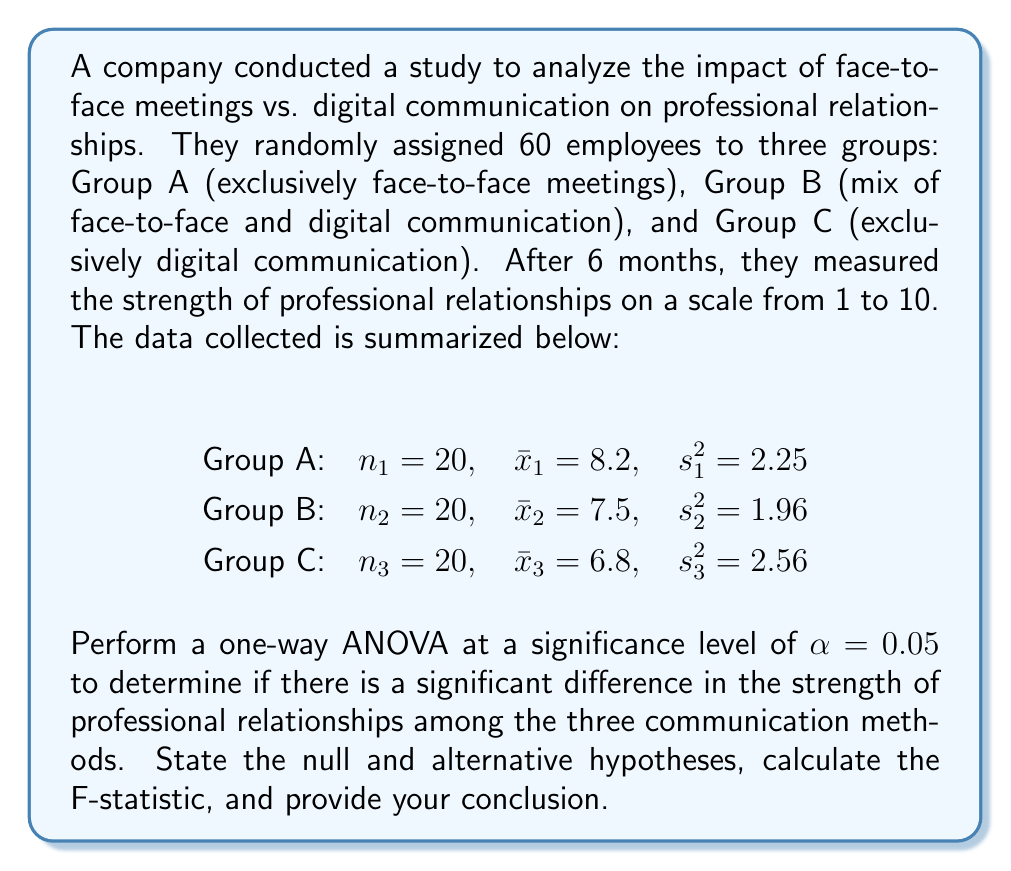Give your solution to this math problem. To perform a one-way ANOVA, we'll follow these steps:

1. State the null and alternative hypotheses:
   $H_0: \mu_1 = \mu_2 = \mu_3$ (There is no difference in mean relationship strength among the groups)
   $H_a:$ At least one mean is different

2. Calculate the sum of squares between groups (SSB):
   $$SSB = \sum_{i=1}^k n_i(\bar{x}_i - \bar{x})^2$$
   
   First, we need to calculate the grand mean:
   $$\bar{x} = \frac{20(8.2) + 20(7.5) + 20(6.8)}{60} = 7.5$$

   Now, we can calculate SSB:
   $$SSB = 20(8.2 - 7.5)^2 + 20(7.5 - 7.5)^2 + 20(6.8 - 7.5)^2 = 19.6$$

3. Calculate the sum of squares within groups (SSW):
   $$SSW = \sum_{i=1}^k (n_i - 1)s_i^2$$
   $$SSW = 19(2.25) + 19(1.96) + 19(2.56) = 128.63$$

4. Calculate the degrees of freedom:
   $df_{between} = k - 1 = 3 - 1 = 2$
   $df_{within} = N - k = 60 - 3 = 57$
   $df_{total} = N - 1 = 60 - 1 = 59$

5. Calculate the mean square between (MSB) and mean square within (MSW):
   $$MSB = \frac{SSB}{df_{between}} = \frac{19.6}{2} = 9.8$$
   $$MSW = \frac{SSW}{df_{within}} = \frac{128.63}{57} = 2.26$$

6. Calculate the F-statistic:
   $$F = \frac{MSB}{MSW} = \frac{9.8}{2.26} = 4.34$$

7. Find the critical F-value:
   For $\alpha = 0.05$, $df_{between} = 2$, and $df_{within} = 57$, the critical F-value is approximately 3.16.

8. Make a decision:
   Since the calculated F-statistic (4.34) is greater than the critical F-value (3.16), we reject the null hypothesis.

9. Conclusion:
   There is sufficient evidence to conclude that there is a significant difference in the strength of professional relationships among the three communication methods at the 0.05 significance level.
Answer: F-statistic = 4.34
Reject the null hypothesis.
There is a significant difference in the strength of professional relationships among the three communication methods (p < 0.05). 